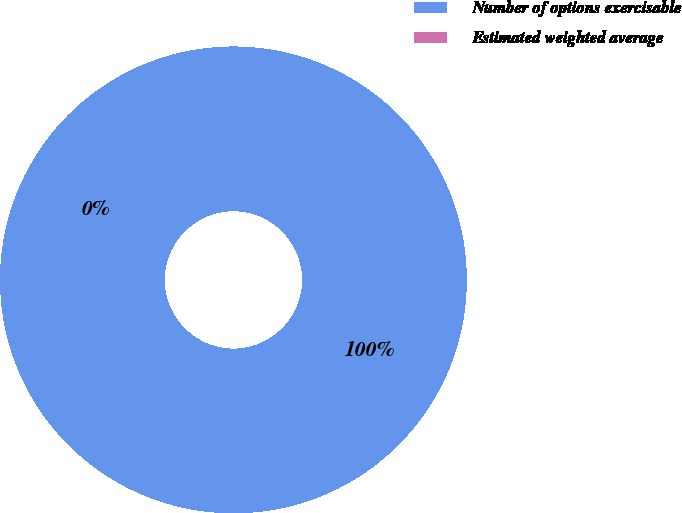Convert chart. <chart><loc_0><loc_0><loc_500><loc_500><pie_chart><fcel>Number of options exercisable<fcel>Estimated weighted average<nl><fcel>100.0%<fcel>0.0%<nl></chart> 